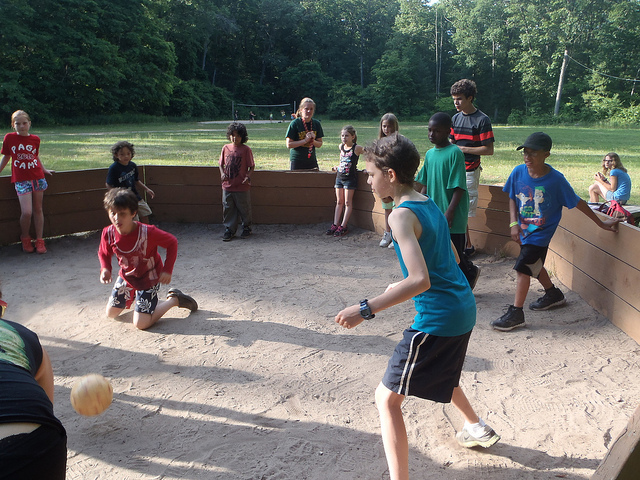Read all the text in this image. CAMP 